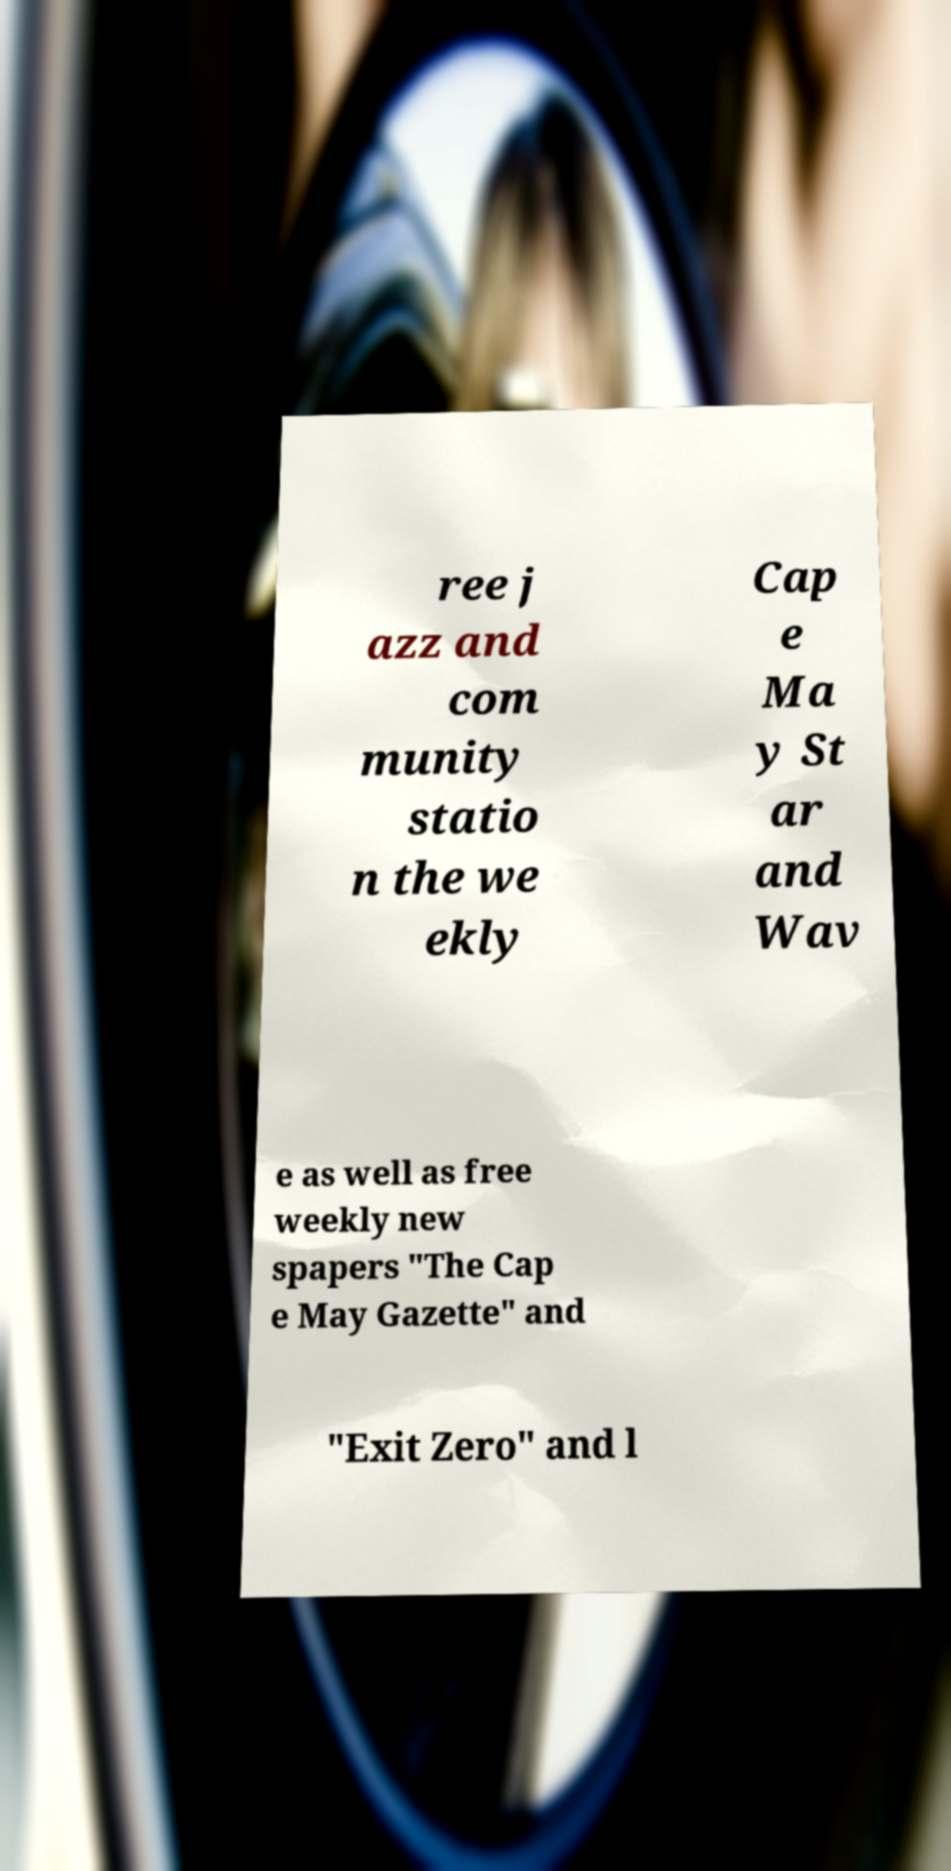Can you read and provide the text displayed in the image?This photo seems to have some interesting text. Can you extract and type it out for me? ree j azz and com munity statio n the we ekly Cap e Ma y St ar and Wav e as well as free weekly new spapers "The Cap e May Gazette" and "Exit Zero" and l 